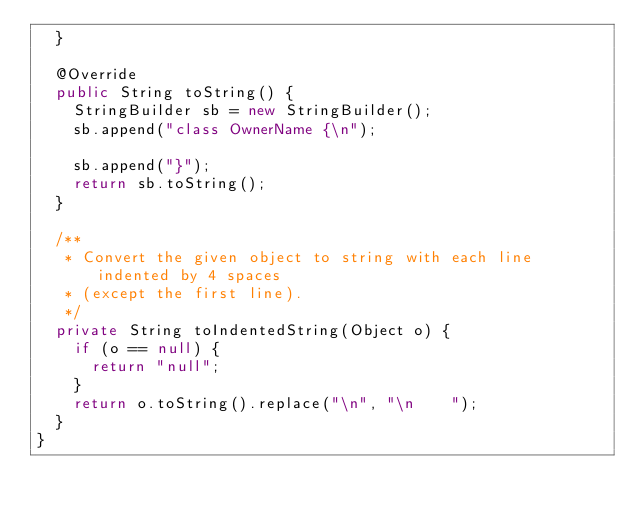<code> <loc_0><loc_0><loc_500><loc_500><_Java_>  }

  @Override
  public String toString() {
    StringBuilder sb = new StringBuilder();
    sb.append("class OwnerName {\n");

    sb.append("}");
    return sb.toString();
  }

  /**
   * Convert the given object to string with each line indented by 4 spaces
   * (except the first line).
   */
  private String toIndentedString(Object o) {
    if (o == null) {
      return "null";
    }
    return o.toString().replace("\n", "\n    ");
  }
}

</code> 